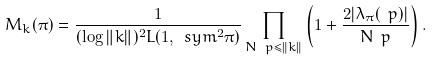<formula> <loc_0><loc_0><loc_500><loc_500>M _ { k } ( \pi ) = \frac { 1 } { ( \log \| k \| ) ^ { 2 } L ( 1 , \ s y m ^ { 2 } \pi ) } \prod _ { N \ p \leq \| k \| } \left ( 1 + \frac { 2 | \lambda _ { \pi } ( \ p ) | } { N \ p } \right ) .</formula> 